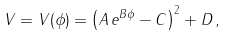<formula> <loc_0><loc_0><loc_500><loc_500>V = V ( \phi ) = \left ( A \, e ^ { B \phi } - C \right ) ^ { 2 } + D \, ,</formula> 